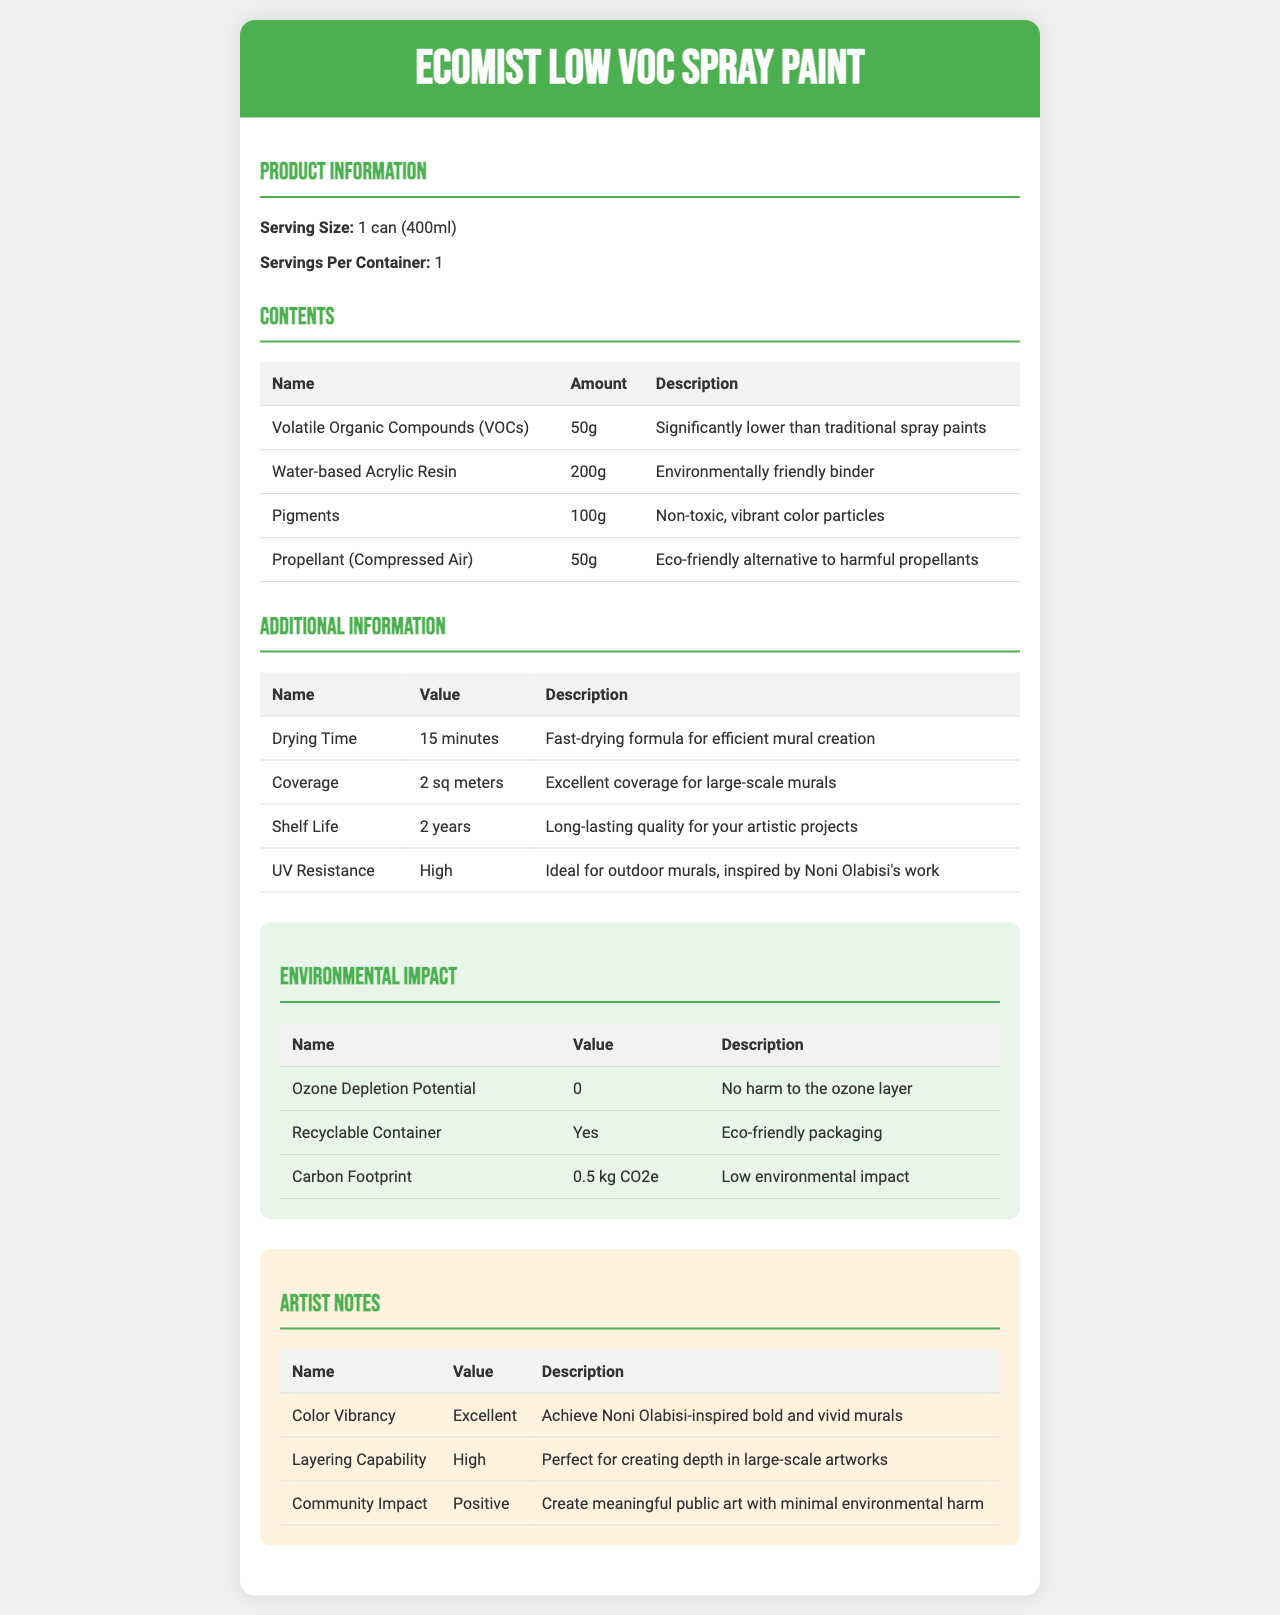who is the product for? The product is "EcoMist Low VOC Spray Paint," which is formulated for muralists, as evident in the artist notes and additional information suitable for creating murals.
Answer: muralists what is the serving size? The serving size is stated as "1 can (400ml)" in the Product Information section.
Answer: 1 can (400ml) how many servings are in one container? The Servings Per Container value is given as "1" in the Product Information section.
Answer: 1 how long does it take to dry? The drying time is mentioned as "15 minutes" in the Additional Information section.
Answer: 15 minutes what is the amount of VOCs present? The amount of Volatile Organic Compounds (VOCs) present is "50g," as listed under the Contents section.
Answer: 50g which ingredient serves as an eco-friendly binder? The Water-based Acrylic Resin is described as an "Environmentally friendly binder" in the Contents section.
Answer: Water-based Acrylic Resin what is the shelf life of the spray paint? A. 1 year B. 2 years C. 3 years The shelf life is given as "2 years" in the Additional Information section.
Answer: B what is the coverage area per can? A. 1 sq meter B. 1.5 sq meters C. 2 sq meters D. 2.5 sq meters The coverage area is listed as "2 sq meters" in the Additional Information section.
Answer: C is the container recyclable? The Environmental Impact section notes that the container is recyclable.
Answer: Yes does the spray paint harm the ozone layer? The Environmental Impact section states that the Ozone Depletion Potential is "0," meaning it causes no harm to the ozone layer.
Answer: No which attribute makes the spray ideal for outdoor murals? The UV Resistance is noted as "High," which makes it ideal for outdoor murals, as mentioned in the Additional Information section.
Answer: High UV Resistance based on the entire document, describe the main benefits of EcoMist Low VOC Spray Paint for muralists. The document provides information on the product's eco-friendly ingredients, additional attributes like fast drying time and high UV resistance, and the positive environmental and artistic impact, making it suitable for creating vibrant, large-scale murals.
Answer: The EcoMist Low VOC Spray Paint offers several benefits for muralists, including low VOC content for reduced environmental impact, an eco-friendly binder, fast drying time, excellent coverage, long shelf life, high UV resistance, non-toxic pigments, and a community-positive impact. It enables the creation of vibrant and bold murals with minimized harm to the environment. how does the carbon footprint compare to other spray paints? The document lists the carbon footprint as "0.5 kg CO2e," but it does not provide information for other spray paints, making a comparison impossible.
Answer: Not enough information what type of propellant is used? The Content section lists the propellant as "Compressed Air," described as an eco-friendly alternative to harmful propellants.
Answer: Compressed Air how much of the contents are pigments? The amount of pigments present is listed as "100g" in the Contents section.
Answer: 100g 